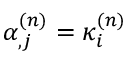<formula> <loc_0><loc_0><loc_500><loc_500>\alpha _ { , j } ^ { ( n ) } = \kappa _ { i } ^ { ( n ) }</formula> 